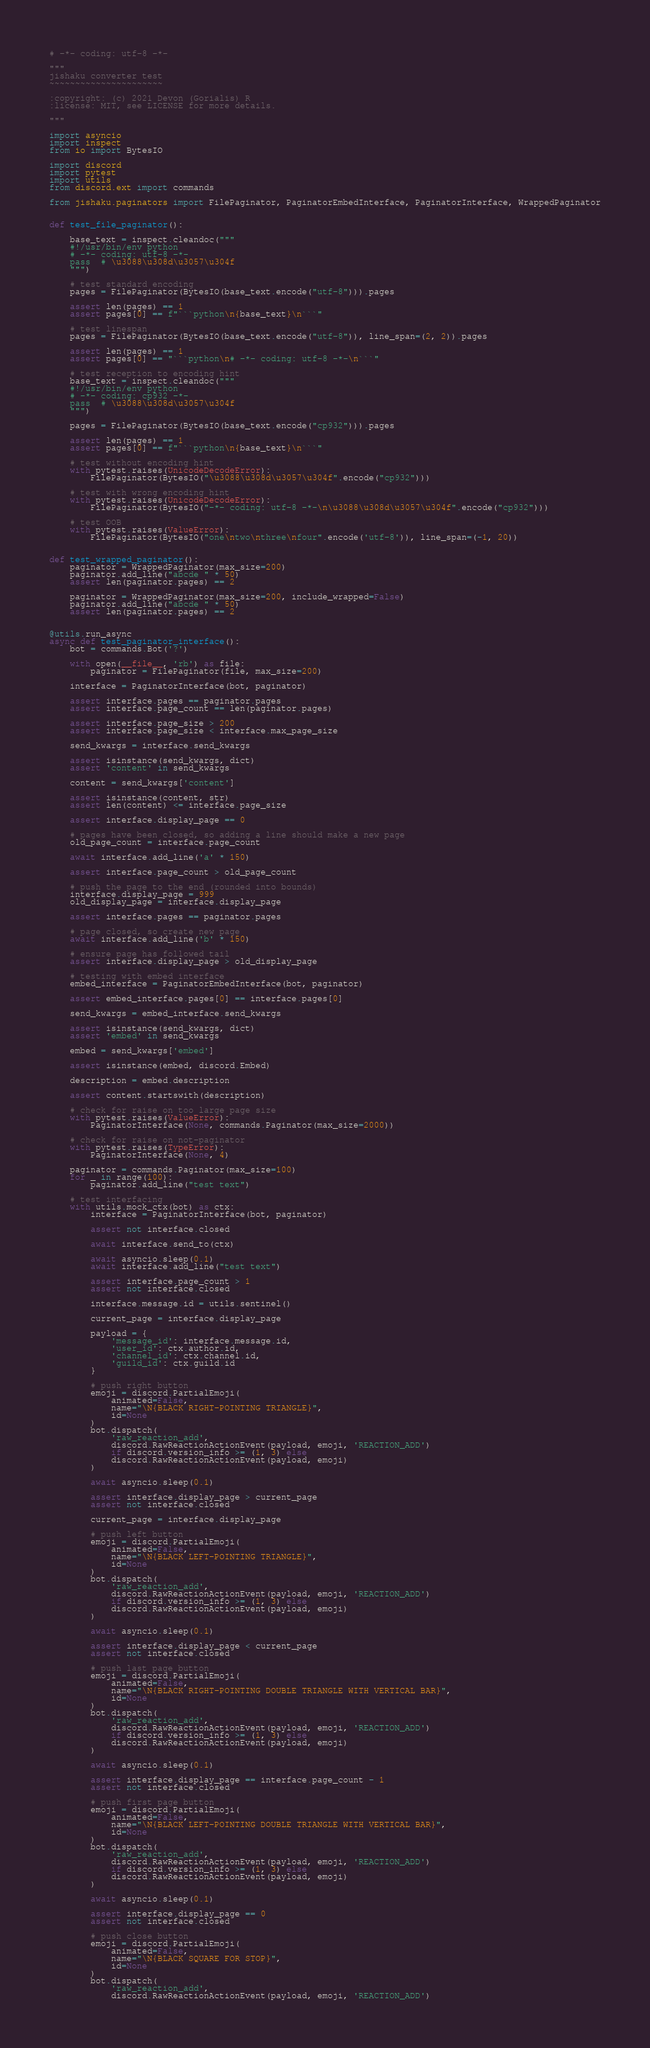Convert code to text. <code><loc_0><loc_0><loc_500><loc_500><_Python_># -*- coding: utf-8 -*-

"""
jishaku converter test
~~~~~~~~~~~~~~~~~~~~~~

:copyright: (c) 2021 Devon (Gorialis) R
:license: MIT, see LICENSE for more details.

"""

import asyncio
import inspect
from io import BytesIO

import discord
import pytest
import utils
from discord.ext import commands

from jishaku.paginators import FilePaginator, PaginatorEmbedInterface, PaginatorInterface, WrappedPaginator


def test_file_paginator():

    base_text = inspect.cleandoc("""
    #!/usr/bin/env python
    # -*- coding: utf-8 -*-
    pass  # \u3088\u308d\u3057\u304f
    """)

    # test standard encoding
    pages = FilePaginator(BytesIO(base_text.encode("utf-8"))).pages

    assert len(pages) == 1
    assert pages[0] == f"```python\n{base_text}\n```"

    # test linespan
    pages = FilePaginator(BytesIO(base_text.encode("utf-8")), line_span=(2, 2)).pages

    assert len(pages) == 1
    assert pages[0] == "```python\n# -*- coding: utf-8 -*-\n```"

    # test reception to encoding hint
    base_text = inspect.cleandoc("""
    #!/usr/bin/env python
    # -*- coding: cp932 -*-
    pass  # \u3088\u308d\u3057\u304f
    """)

    pages = FilePaginator(BytesIO(base_text.encode("cp932"))).pages

    assert len(pages) == 1
    assert pages[0] == f"```python\n{base_text}\n```"

    # test without encoding hint
    with pytest.raises(UnicodeDecodeError):
        FilePaginator(BytesIO("\u3088\u308d\u3057\u304f".encode("cp932")))

    # test with wrong encoding hint
    with pytest.raises(UnicodeDecodeError):
        FilePaginator(BytesIO("-*- coding: utf-8 -*-\n\u3088\u308d\u3057\u304f".encode("cp932")))

    # test OOB
    with pytest.raises(ValueError):
        FilePaginator(BytesIO("one\ntwo\nthree\nfour".encode('utf-8')), line_span=(-1, 20))


def test_wrapped_paginator():
    paginator = WrappedPaginator(max_size=200)
    paginator.add_line("abcde " * 50)
    assert len(paginator.pages) == 2

    paginator = WrappedPaginator(max_size=200, include_wrapped=False)
    paginator.add_line("abcde " * 50)
    assert len(paginator.pages) == 2


@utils.run_async
async def test_paginator_interface():
    bot = commands.Bot('?')

    with open(__file__, 'rb') as file:
        paginator = FilePaginator(file, max_size=200)

    interface = PaginatorInterface(bot, paginator)

    assert interface.pages == paginator.pages
    assert interface.page_count == len(paginator.pages)

    assert interface.page_size > 200
    assert interface.page_size < interface.max_page_size

    send_kwargs = interface.send_kwargs

    assert isinstance(send_kwargs, dict)
    assert 'content' in send_kwargs

    content = send_kwargs['content']

    assert isinstance(content, str)
    assert len(content) <= interface.page_size

    assert interface.display_page == 0

    # pages have been closed, so adding a line should make a new page
    old_page_count = interface.page_count

    await interface.add_line('a' * 150)

    assert interface.page_count > old_page_count

    # push the page to the end (rounded into bounds)
    interface.display_page = 999
    old_display_page = interface.display_page

    assert interface.pages == paginator.pages

    # page closed, so create new page
    await interface.add_line('b' * 150)

    # ensure page has followed tail
    assert interface.display_page > old_display_page

    # testing with embed interface
    embed_interface = PaginatorEmbedInterface(bot, paginator)

    assert embed_interface.pages[0] == interface.pages[0]

    send_kwargs = embed_interface.send_kwargs

    assert isinstance(send_kwargs, dict)
    assert 'embed' in send_kwargs

    embed = send_kwargs['embed']

    assert isinstance(embed, discord.Embed)

    description = embed.description

    assert content.startswith(description)

    # check for raise on too large page size
    with pytest.raises(ValueError):
        PaginatorInterface(None, commands.Paginator(max_size=2000))

    # check for raise on not-paginator
    with pytest.raises(TypeError):
        PaginatorInterface(None, 4)

    paginator = commands.Paginator(max_size=100)
    for _ in range(100):
        paginator.add_line("test text")

    # test interfacing
    with utils.mock_ctx(bot) as ctx:
        interface = PaginatorInterface(bot, paginator)

        assert not interface.closed

        await interface.send_to(ctx)

        await asyncio.sleep(0.1)
        await interface.add_line("test text")

        assert interface.page_count > 1
        assert not interface.closed

        interface.message.id = utils.sentinel()

        current_page = interface.display_page

        payload = {
            'message_id': interface.message.id,
            'user_id': ctx.author.id,
            'channel_id': ctx.channel.id,
            'guild_id': ctx.guild.id
        }

        # push right button
        emoji = discord.PartialEmoji(
            animated=False,
            name="\N{BLACK RIGHT-POINTING TRIANGLE}",
            id=None
        )
        bot.dispatch(
            'raw_reaction_add',
            discord.RawReactionActionEvent(payload, emoji, 'REACTION_ADD')
            if discord.version_info >= (1, 3) else
            discord.RawReactionActionEvent(payload, emoji)
        )

        await asyncio.sleep(0.1)

        assert interface.display_page > current_page
        assert not interface.closed

        current_page = interface.display_page

        # push left button
        emoji = discord.PartialEmoji(
            animated=False,
            name="\N{BLACK LEFT-POINTING TRIANGLE}",
            id=None
        )
        bot.dispatch(
            'raw_reaction_add',
            discord.RawReactionActionEvent(payload, emoji, 'REACTION_ADD')
            if discord.version_info >= (1, 3) else
            discord.RawReactionActionEvent(payload, emoji)
        )

        await asyncio.sleep(0.1)

        assert interface.display_page < current_page
        assert not interface.closed

        # push last page button
        emoji = discord.PartialEmoji(
            animated=False,
            name="\N{BLACK RIGHT-POINTING DOUBLE TRIANGLE WITH VERTICAL BAR}",
            id=None
        )
        bot.dispatch(
            'raw_reaction_add',
            discord.RawReactionActionEvent(payload, emoji, 'REACTION_ADD')
            if discord.version_info >= (1, 3) else
            discord.RawReactionActionEvent(payload, emoji)
        )

        await asyncio.sleep(0.1)

        assert interface.display_page == interface.page_count - 1
        assert not interface.closed

        # push first page button
        emoji = discord.PartialEmoji(
            animated=False,
            name="\N{BLACK LEFT-POINTING DOUBLE TRIANGLE WITH VERTICAL BAR}",
            id=None
        )
        bot.dispatch(
            'raw_reaction_add',
            discord.RawReactionActionEvent(payload, emoji, 'REACTION_ADD')
            if discord.version_info >= (1, 3) else
            discord.RawReactionActionEvent(payload, emoji)
        )

        await asyncio.sleep(0.1)

        assert interface.display_page == 0
        assert not interface.closed

        # push close button
        emoji = discord.PartialEmoji(
            animated=False,
            name="\N{BLACK SQUARE FOR STOP}",
            id=None
        )
        bot.dispatch(
            'raw_reaction_add',
            discord.RawReactionActionEvent(payload, emoji, 'REACTION_ADD')</code> 